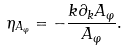<formula> <loc_0><loc_0><loc_500><loc_500>\eta _ { A _ { \varphi } } = - \frac { k \partial _ { k } A _ { \varphi } } { A _ { \varphi } } .</formula> 